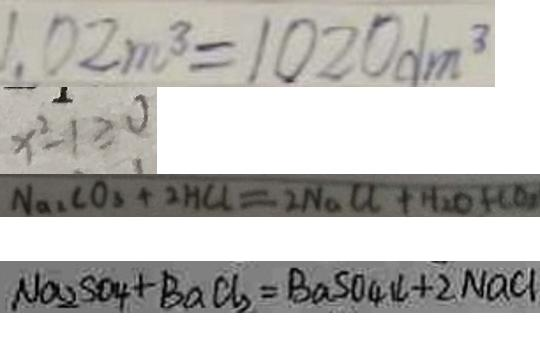<formula> <loc_0><loc_0><loc_500><loc_500>1 . 0 2 m ^ { 3 } = 1 0 2 0 d m ^ { 3 } 
 x ^ { 2 } - 1 \geq 0 
 N a _ { 3 } C O _ { 3 } + 2 H C l = 2 N a C O + H _ { 2 } O + C O _ { 2 } 
 N a _ { 2 } S O _ { 4 } + B a C l _ { 2 } = B a S O _ { 4 } \downarrow + 2 N a C l</formula> 